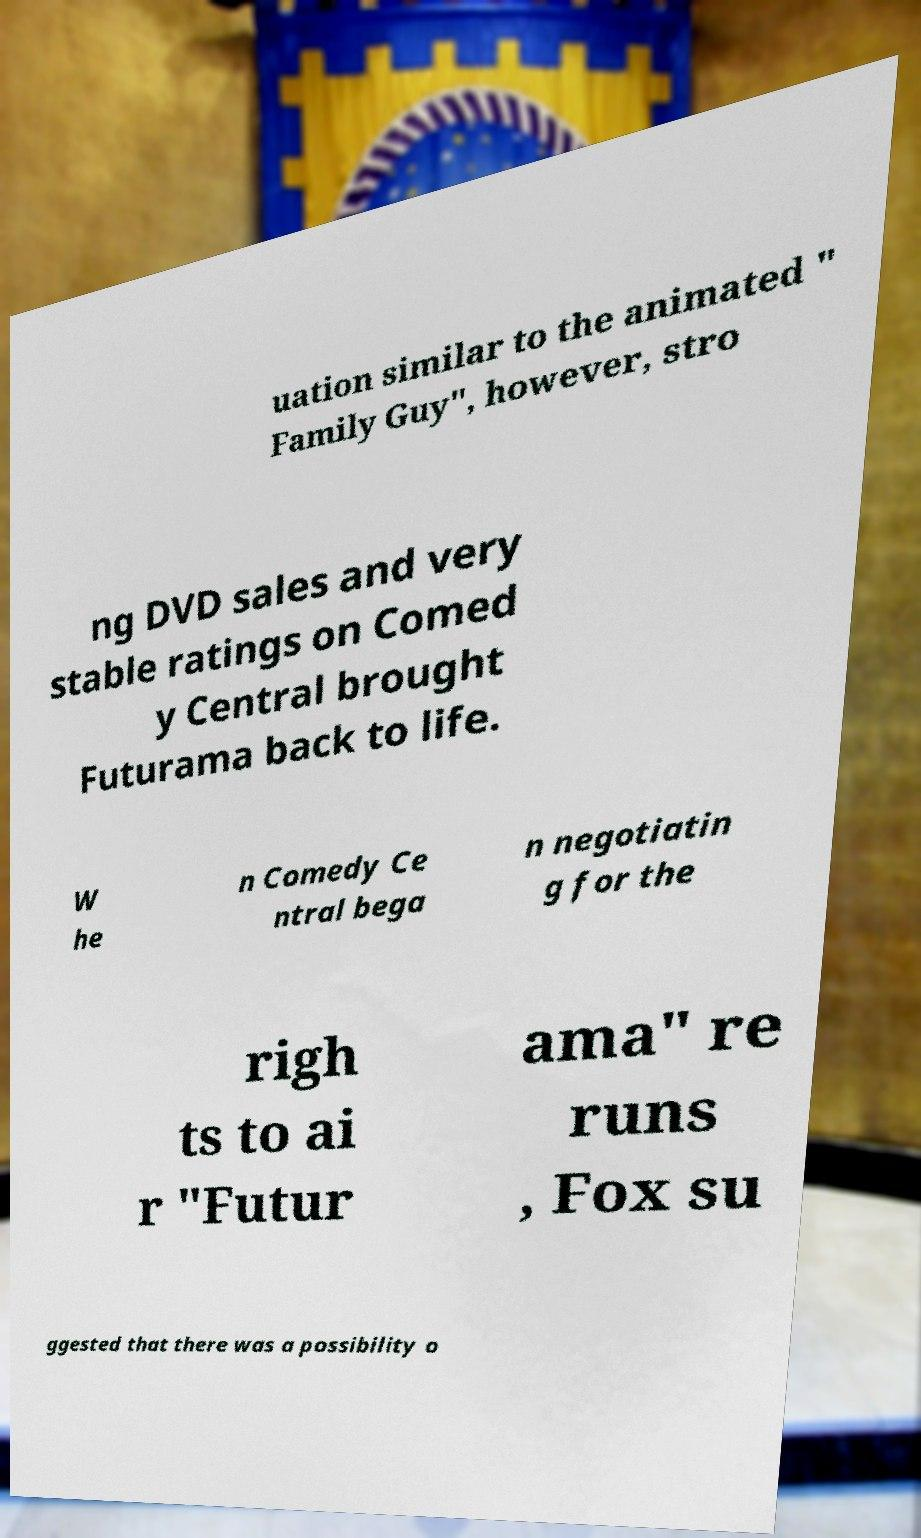For documentation purposes, I need the text within this image transcribed. Could you provide that? uation similar to the animated " Family Guy", however, stro ng DVD sales and very stable ratings on Comed y Central brought Futurama back to life. W he n Comedy Ce ntral bega n negotiatin g for the righ ts to ai r "Futur ama" re runs , Fox su ggested that there was a possibility o 